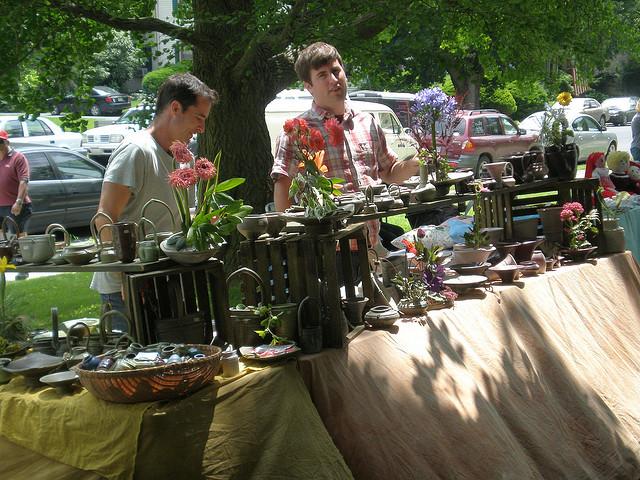What event is taking place in the picture?
Concise answer only. Yard sale. What color is the station wagon in the background?
Concise answer only. Red. Is there a slight chill in the air?
Be succinct. No. Is the season fall?
Concise answer only. No. 